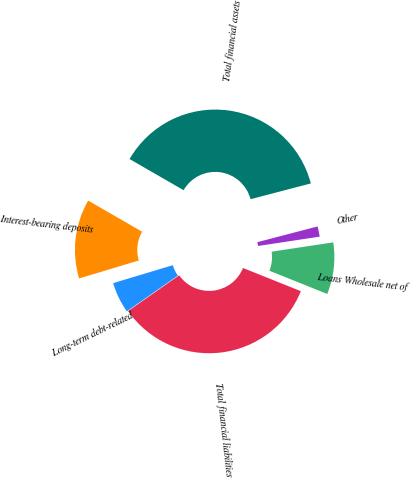Convert chart. <chart><loc_0><loc_0><loc_500><loc_500><pie_chart><fcel>Loans Wholesale net of<fcel>Other<fcel>Total financial assets<fcel>Interest-bearing deposits<fcel>Long-term debt-related<fcel>Total financial liabilities<nl><fcel>8.46%<fcel>1.68%<fcel>37.6%<fcel>12.97%<fcel>5.07%<fcel>34.21%<nl></chart> 